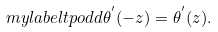Convert formula to latex. <formula><loc_0><loc_0><loc_500><loc_500>\ m y l a b e l { t p o d d } \theta ^ { ^ { \prime } } ( - z ) = \theta ^ { ^ { \prime } } ( z ) .</formula> 